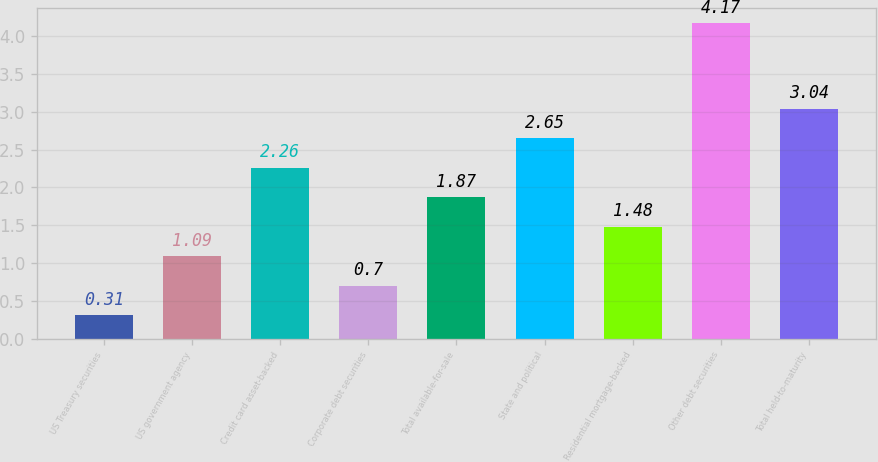Convert chart. <chart><loc_0><loc_0><loc_500><loc_500><bar_chart><fcel>US Treasury securities<fcel>US government agency<fcel>Credit card asset-backed<fcel>Corporate debt securities<fcel>Total available-for-sale<fcel>State and political<fcel>Residential mortgage-backed<fcel>Other debt securities<fcel>Total held-to-maturity<nl><fcel>0.31<fcel>1.09<fcel>2.26<fcel>0.7<fcel>1.87<fcel>2.65<fcel>1.48<fcel>4.17<fcel>3.04<nl></chart> 